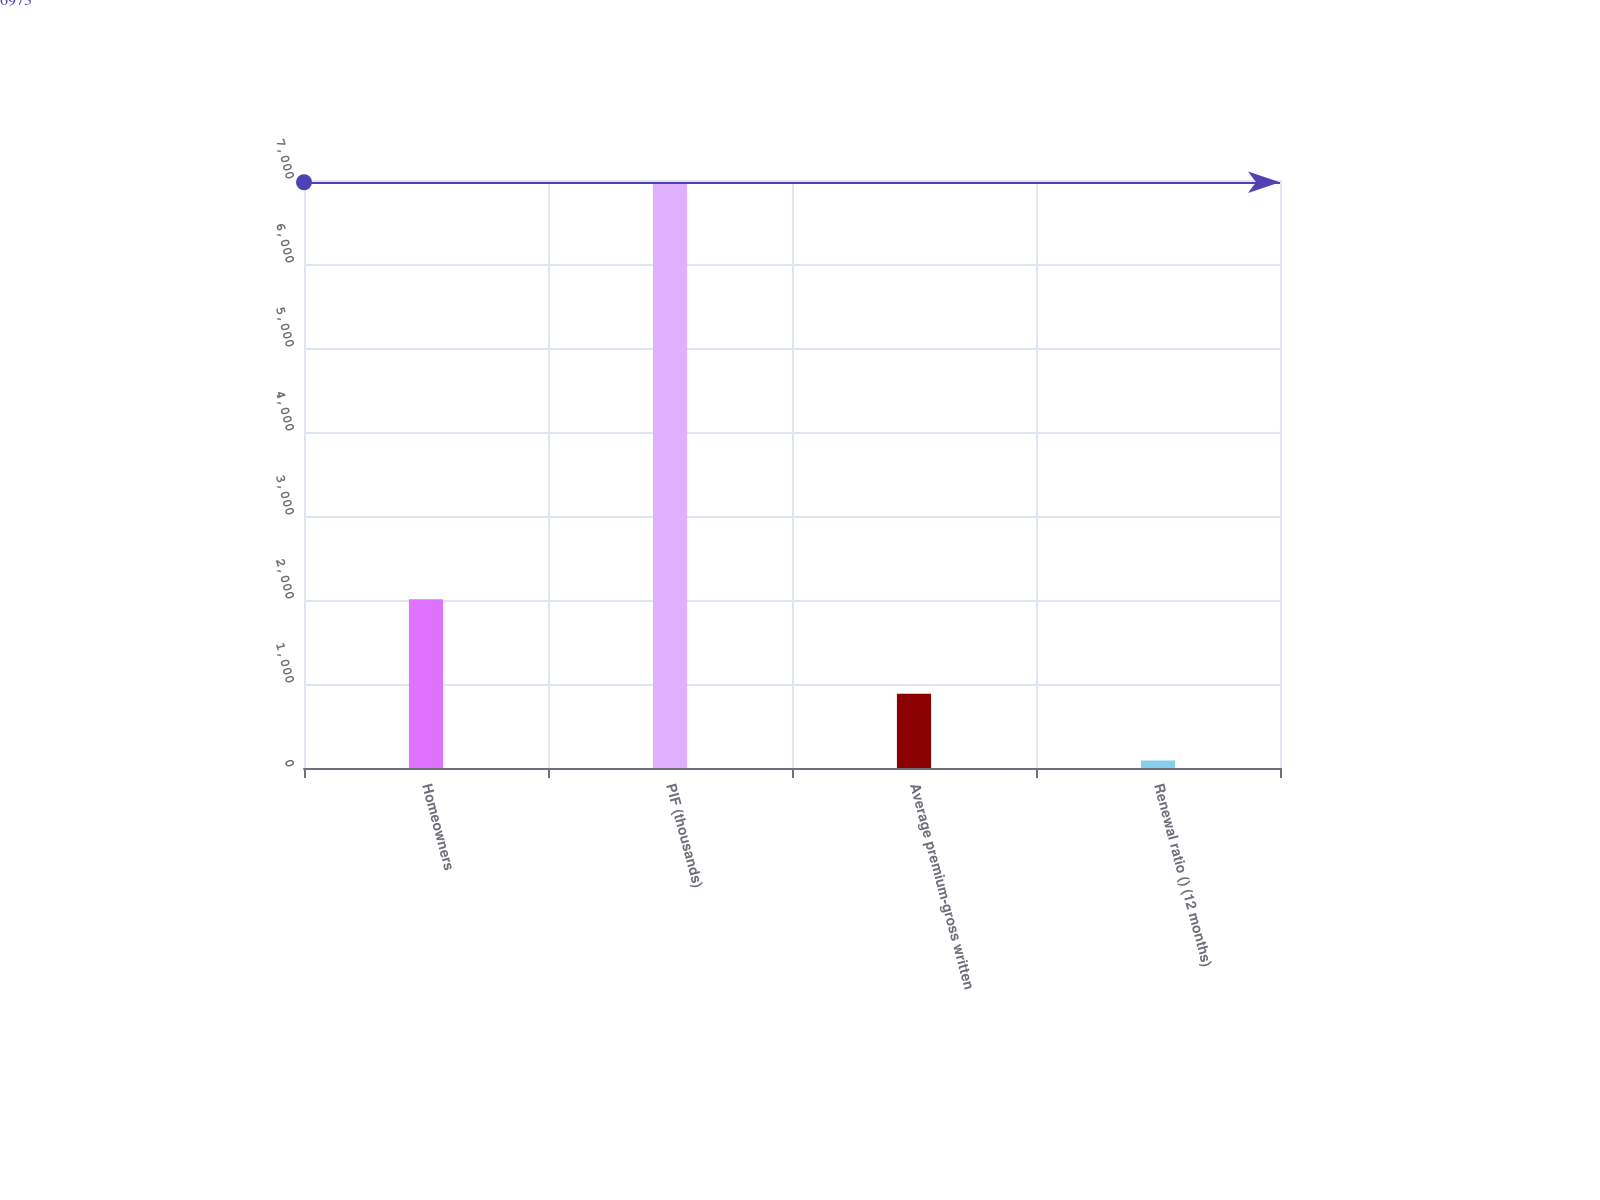Convert chart to OTSL. <chart><loc_0><loc_0><loc_500><loc_500><bar_chart><fcel>Homeowners<fcel>PIF (thousands)<fcel>Average premium-gross written<fcel>Renewal ratio () (12 months)<nl><fcel>2009<fcel>6973<fcel>883<fcel>88.1<nl></chart> 